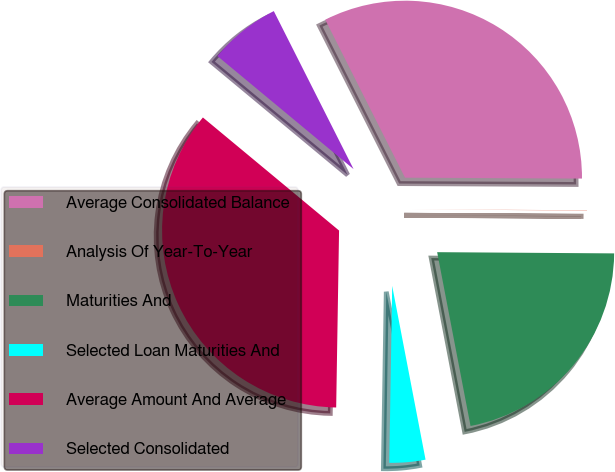Convert chart to OTSL. <chart><loc_0><loc_0><loc_500><loc_500><pie_chart><fcel>Average Consolidated Balance<fcel>Analysis Of Year-To-Year<fcel>Maturities And<fcel>Selected Loan Maturities And<fcel>Average Amount And Average<fcel>Selected Consolidated<nl><fcel>32.52%<fcel>0.03%<fcel>21.87%<fcel>3.28%<fcel>35.77%<fcel>6.53%<nl></chart> 